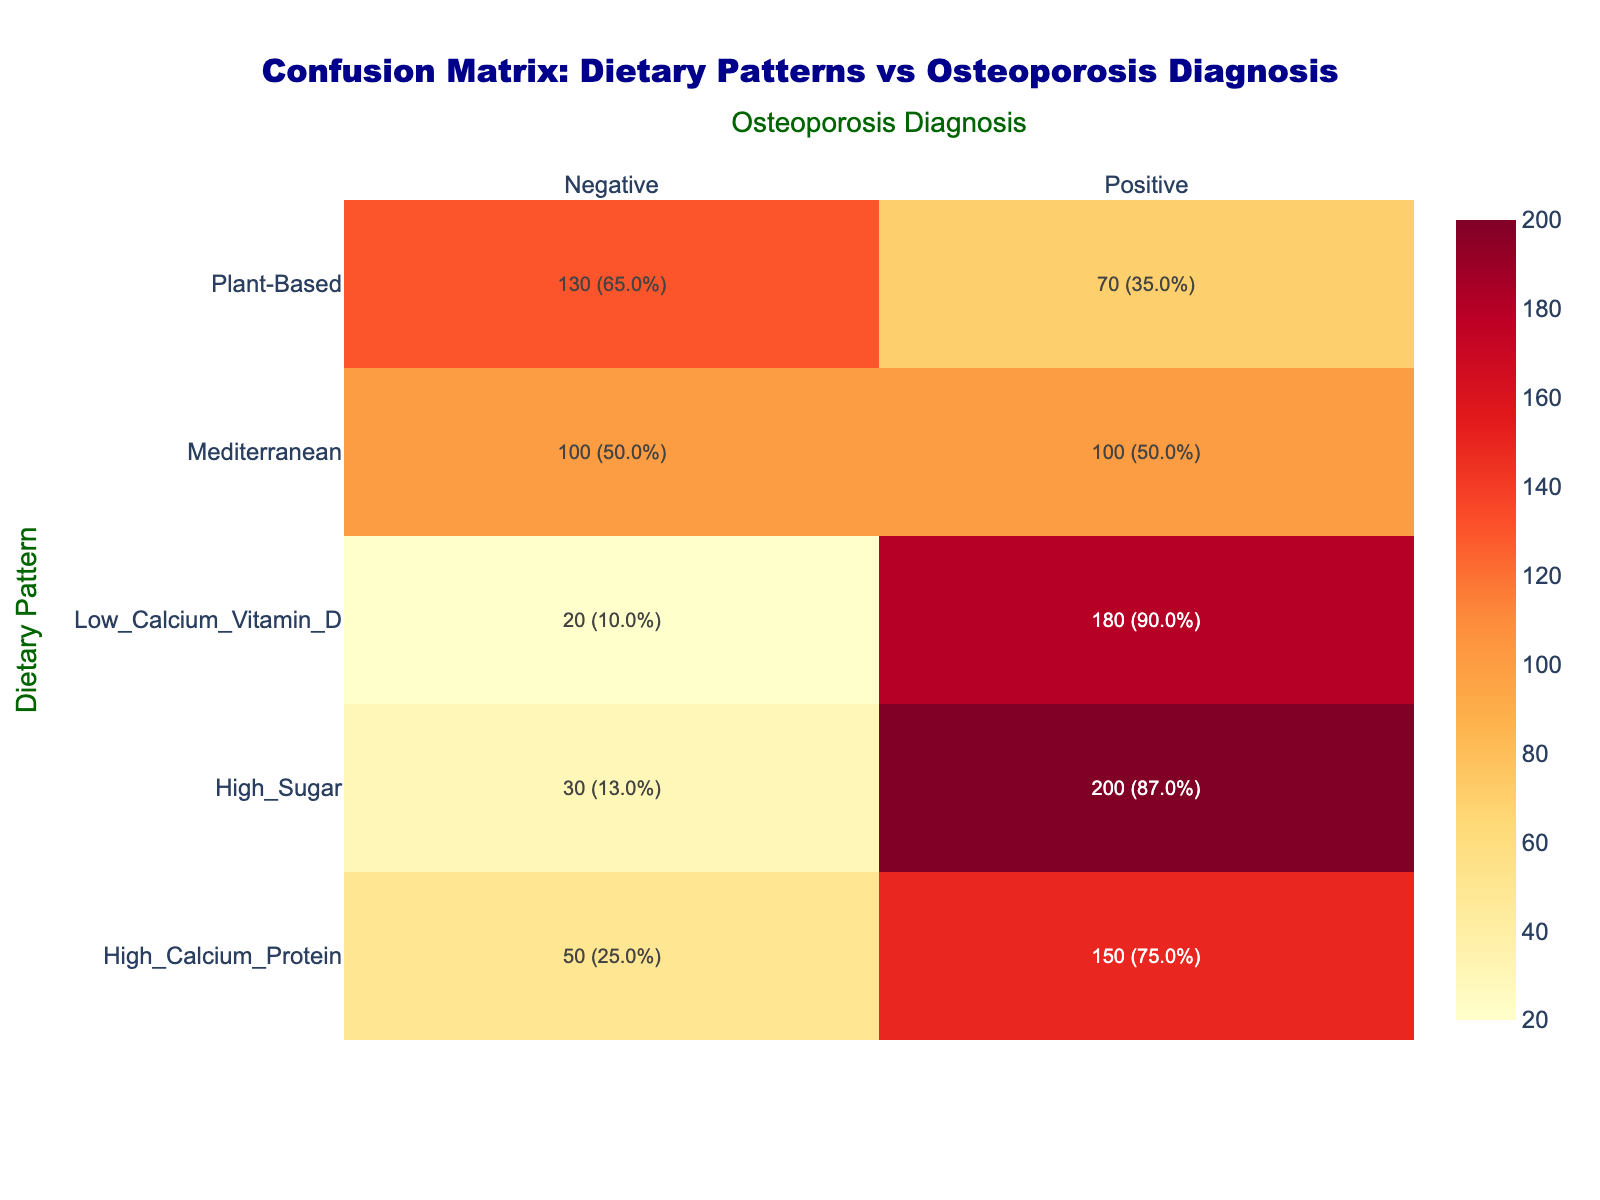What is the count of patients with a Mediterranean dietary pattern who were diagnosed with osteoporosis? According to the table, for the Mediterranean dietary pattern, under the Osteoporosis Diagnosis column, the count for "Positive" is listed as 100.
Answer: 100 How many patients in total were diagnosed as positive for osteoporosis across all dietary patterns? To find the total number of positive diagnoses, we sum the counts for all dietary patterns where the diagnosis is positive: 150 (High Calcium Protein) + 180 (Low Calcium Vitamin D) + 100 (Mediterranean) + 200 (High Sugar) + 70 (Plant-Based) = 800.
Answer: 800 Did any patients following a Plant-Based dietary pattern receive a positive diagnosis for osteoporosis? In the data for the Plant-Based dietary pattern, the count for "Positive" is specified as 70, indicating that there were indeed patients with this dietary pattern diagnosed positively.
Answer: Yes What is the percentage of patients with a High Sugar dietary pattern that were not diagnosed with osteoporosis? The count of patients with a High Sugar dietary pattern who were negative for osteoporosis is 30. The total count for this pattern is 200 (positive) + 30 (negative) = 230. Therefore, the percentage is (30/230) * 100 ≈ 13.0%.
Answer: 13.0% Which dietary pattern has the highest proportion of positive osteoporosis diagnoses? First, we calculate the proportions for each dietary pattern by dividing the positive counts by the total counts for each pattern: High Calcium Protein: 150/(150+50) = 0.75; Low Calcium Vitamin D: 180/(180+20) = 0.9; Mediterranean: 100/(100+100) = 0.5; High Sugar: 200/(200+30) ≈ 0.87; Plant-Based: 70/(70+130) = 0.35. The pattern with the highest proportion is Low Calcium Vitamin D with 0.9.
Answer: Low Calcium Vitamin D How many patients were diagnosed with osteoporosis who were not following a High Sugar dietary pattern? The total number of positive diagnoses is 800, and the count of positive cases for High Sugar is 200. Subtracting those gives: 800 - 200 = 600.
Answer: 600 